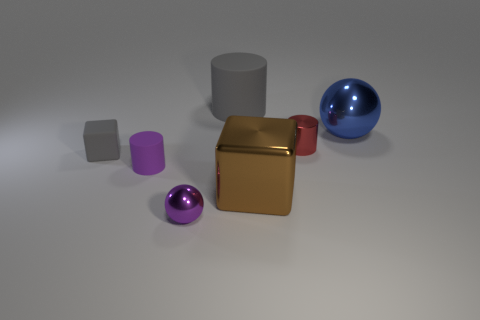Does the small red cylinder have the same material as the small cube?
Your answer should be compact. No. What size is the object that is the same color as the rubber block?
Your answer should be compact. Large. What is the gray cylinder made of?
Offer a very short reply. Rubber. There is a rubber object that is behind the small purple matte object and right of the gray rubber cube; what is its size?
Keep it short and to the point. Large. How many other objects are the same shape as the small red thing?
Provide a short and direct response. 2. There is a purple metallic thing; is it the same shape as the big shiny thing behind the tiny purple matte cylinder?
Give a very brief answer. Yes. How many cubes are on the left side of the big cylinder?
Offer a very short reply. 1. Is there any other thing that has the same material as the small gray thing?
Provide a succinct answer. Yes. There is a small shiny object in front of the tiny purple cylinder; does it have the same shape as the large blue metallic object?
Make the answer very short. Yes. There is a matte cylinder behind the large ball; what is its color?
Make the answer very short. Gray. 